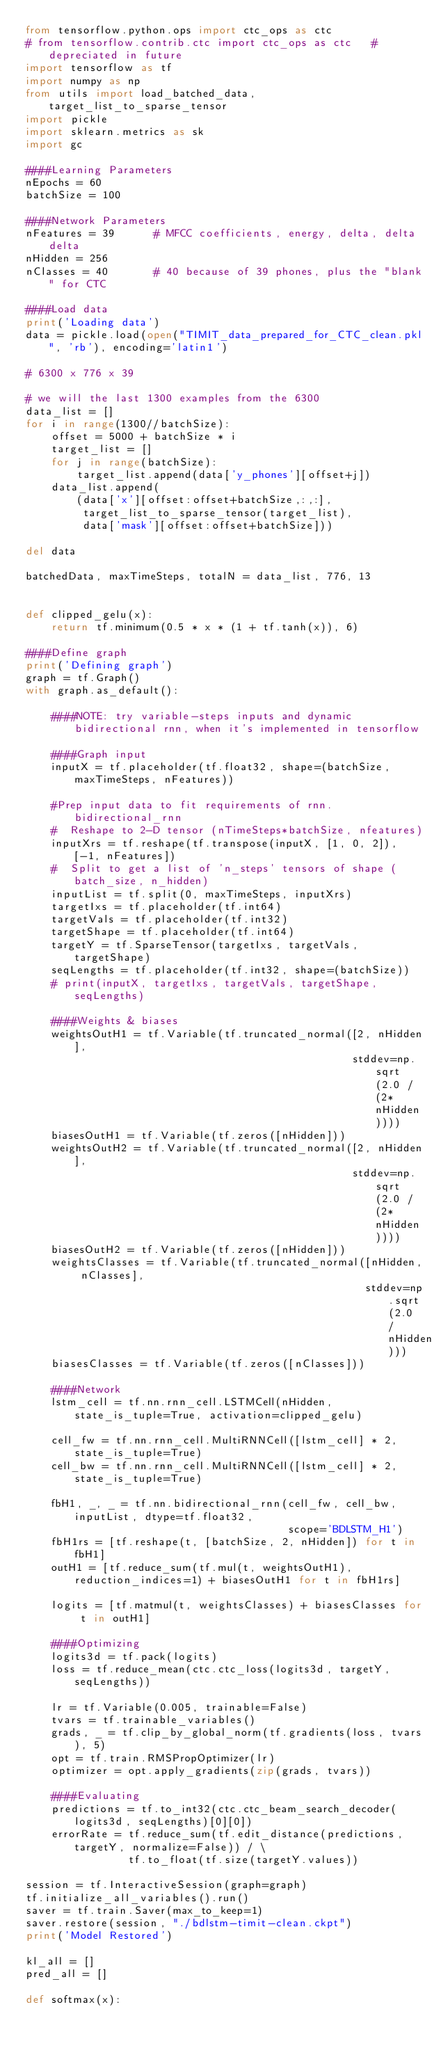<code> <loc_0><loc_0><loc_500><loc_500><_Python_>from tensorflow.python.ops import ctc_ops as ctc
# from tensorflow.contrib.ctc import ctc_ops as ctc   # depreciated in future
import tensorflow as tf
import numpy as np
from utils import load_batched_data, target_list_to_sparse_tensor
import pickle
import sklearn.metrics as sk
import gc

####Learning Parameters
nEpochs = 60
batchSize = 100

####Network Parameters
nFeatures = 39      # MFCC coefficients, energy, delta, delta delta
nHidden = 256
nClasses = 40       # 40 because of 39 phones, plus the "blank" for CTC

####Load data
print('Loading data')
data = pickle.load(open("TIMIT_data_prepared_for_CTC_clean.pkl", 'rb'), encoding='latin1')

# 6300 x 776 x 39

# we will the last 1300 examples from the 6300
data_list = []
for i in range(1300//batchSize):
    offset = 5000 + batchSize * i
    target_list = []
    for j in range(batchSize):
        target_list.append(data['y_phones'][offset+j])
    data_list.append(
        (data['x'][offset:offset+batchSize,:,:],
         target_list_to_sparse_tensor(target_list),
         data['mask'][offset:offset+batchSize]))

del data

batchedData, maxTimeSteps, totalN = data_list, 776, 13


def clipped_gelu(x):
    return tf.minimum(0.5 * x * (1 + tf.tanh(x)), 6)

####Define graph
print('Defining graph')
graph = tf.Graph()
with graph.as_default():

    ####NOTE: try variable-steps inputs and dynamic bidirectional rnn, when it's implemented in tensorflow

    ####Graph input
    inputX = tf.placeholder(tf.float32, shape=(batchSize, maxTimeSteps, nFeatures))

    #Prep input data to fit requirements of rnn.bidirectional_rnn
    #  Reshape to 2-D tensor (nTimeSteps*batchSize, nfeatures)
    inputXrs = tf.reshape(tf.transpose(inputX, [1, 0, 2]), [-1, nFeatures])
    #  Split to get a list of 'n_steps' tensors of shape (batch_size, n_hidden)
    inputList = tf.split(0, maxTimeSteps, inputXrs)
    targetIxs = tf.placeholder(tf.int64)
    targetVals = tf.placeholder(tf.int32)
    targetShape = tf.placeholder(tf.int64)
    targetY = tf.SparseTensor(targetIxs, targetVals, targetShape)
    seqLengths = tf.placeholder(tf.int32, shape=(batchSize))
    # print(inputX, targetIxs, targetVals, targetShape, seqLengths)

    ####Weights & biases
    weightsOutH1 = tf.Variable(tf.truncated_normal([2, nHidden],
                                                   stddev=np.sqrt(2.0 / (2*nHidden))))
    biasesOutH1 = tf.Variable(tf.zeros([nHidden]))
    weightsOutH2 = tf.Variable(tf.truncated_normal([2, nHidden],
                                                   stddev=np.sqrt(2.0 / (2*nHidden))))
    biasesOutH2 = tf.Variable(tf.zeros([nHidden]))
    weightsClasses = tf.Variable(tf.truncated_normal([nHidden, nClasses],
                                                     stddev=np.sqrt(2.0 / nHidden)))
    biasesClasses = tf.Variable(tf.zeros([nClasses]))

    ####Network
    lstm_cell = tf.nn.rnn_cell.LSTMCell(nHidden, state_is_tuple=True, activation=clipped_gelu)

    cell_fw = tf.nn.rnn_cell.MultiRNNCell([lstm_cell] * 2, state_is_tuple=True)
    cell_bw = tf.nn.rnn_cell.MultiRNNCell([lstm_cell] * 2, state_is_tuple=True)

    fbH1, _, _ = tf.nn.bidirectional_rnn(cell_fw, cell_bw, inputList, dtype=tf.float32,
                                         scope='BDLSTM_H1')
    fbH1rs = [tf.reshape(t, [batchSize, 2, nHidden]) for t in fbH1]
    outH1 = [tf.reduce_sum(tf.mul(t, weightsOutH1), reduction_indices=1) + biasesOutH1 for t in fbH1rs]

    logits = [tf.matmul(t, weightsClasses) + biasesClasses for t in outH1]

    ####Optimizing
    logits3d = tf.pack(logits)
    loss = tf.reduce_mean(ctc.ctc_loss(logits3d, targetY, seqLengths))

    lr = tf.Variable(0.005, trainable=False)
    tvars = tf.trainable_variables()
    grads, _ = tf.clip_by_global_norm(tf.gradients(loss, tvars), 5)
    opt = tf.train.RMSPropOptimizer(lr)
    optimizer = opt.apply_gradients(zip(grads, tvars))

    ####Evaluating
    predictions = tf.to_int32(ctc.ctc_beam_search_decoder(logits3d, seqLengths)[0][0])
    errorRate = tf.reduce_sum(tf.edit_distance(predictions, targetY, normalize=False)) / \
                tf.to_float(tf.size(targetY.values))

session = tf.InteractiveSession(graph=graph)
tf.initialize_all_variables().run()
saver = tf.train.Saver(max_to_keep=1)
saver.restore(session, "./bdlstm-timit-clean.ckpt")
print('Model Restored')

kl_all = []
pred_all = []

def softmax(x):</code> 